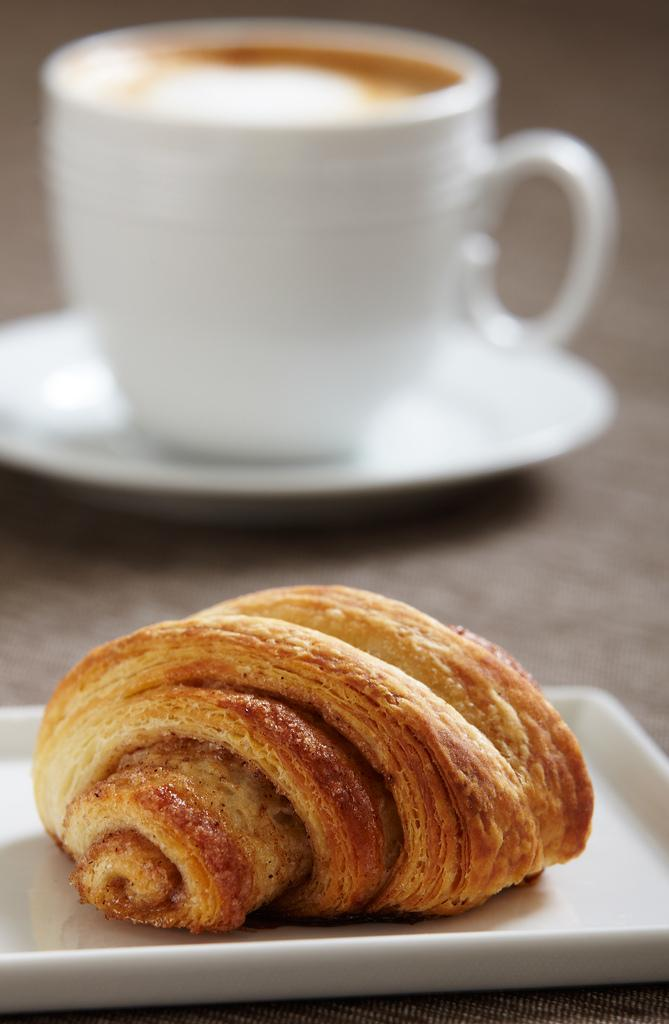What type of cup is visible in the image? There is a white color coffee cup in the image. Where is the coffee cup located in the image? The coffee cup is on the top of the image. What other food item can be seen in the image? There is a snack item in the image. How is the snack item contained in the image? The snack item is kept in a white color bowl. Where is the bowl with the snack item located in the image? The bowl is in the bottom of the image. What type of tax is being discussed in the image? There is no discussion of tax in the image; it features a white color coffee cup, a snack item in a white color bowl, and their respective locations. 